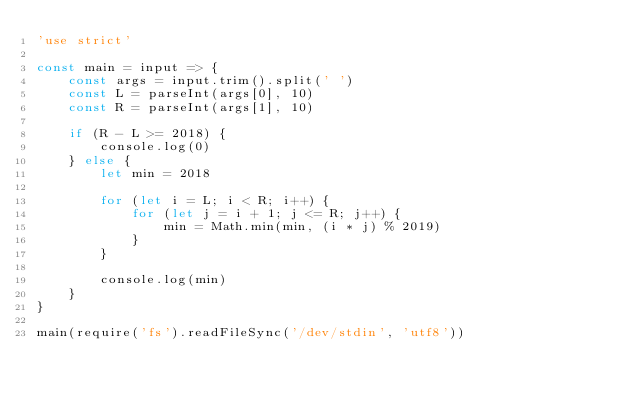<code> <loc_0><loc_0><loc_500><loc_500><_JavaScript_>'use strict'

const main = input => {
	const args = input.trim().split(' ')
	const L = parseInt(args[0], 10)
	const R = parseInt(args[1], 10)
	
	if (R - L >= 2018) {
		console.log(0)
	} else {
		let min = 2018

		for (let i = L; i < R; i++) {
			for (let j = i + 1; j <= R; j++) {
				min = Math.min(min, (i * j) % 2019)
			}
		}

		console.log(min)
	}
}

main(require('fs').readFileSync('/dev/stdin', 'utf8'))
</code> 